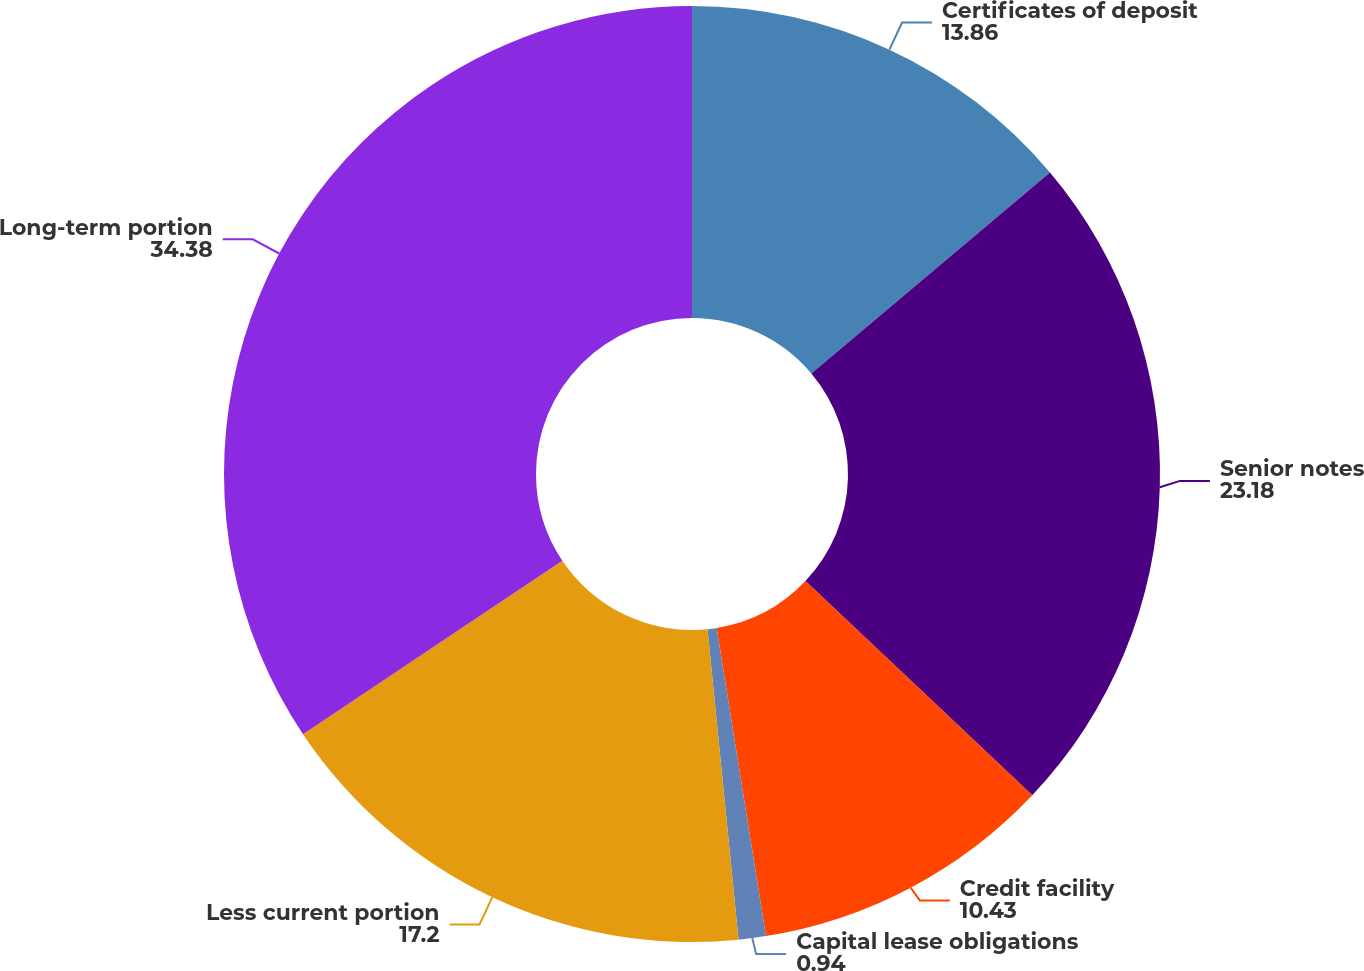Convert chart. <chart><loc_0><loc_0><loc_500><loc_500><pie_chart><fcel>Certificates of deposit<fcel>Senior notes<fcel>Credit facility<fcel>Capital lease obligations<fcel>Less current portion<fcel>Long-term portion<nl><fcel>13.86%<fcel>23.18%<fcel>10.43%<fcel>0.94%<fcel>17.2%<fcel>34.38%<nl></chart> 